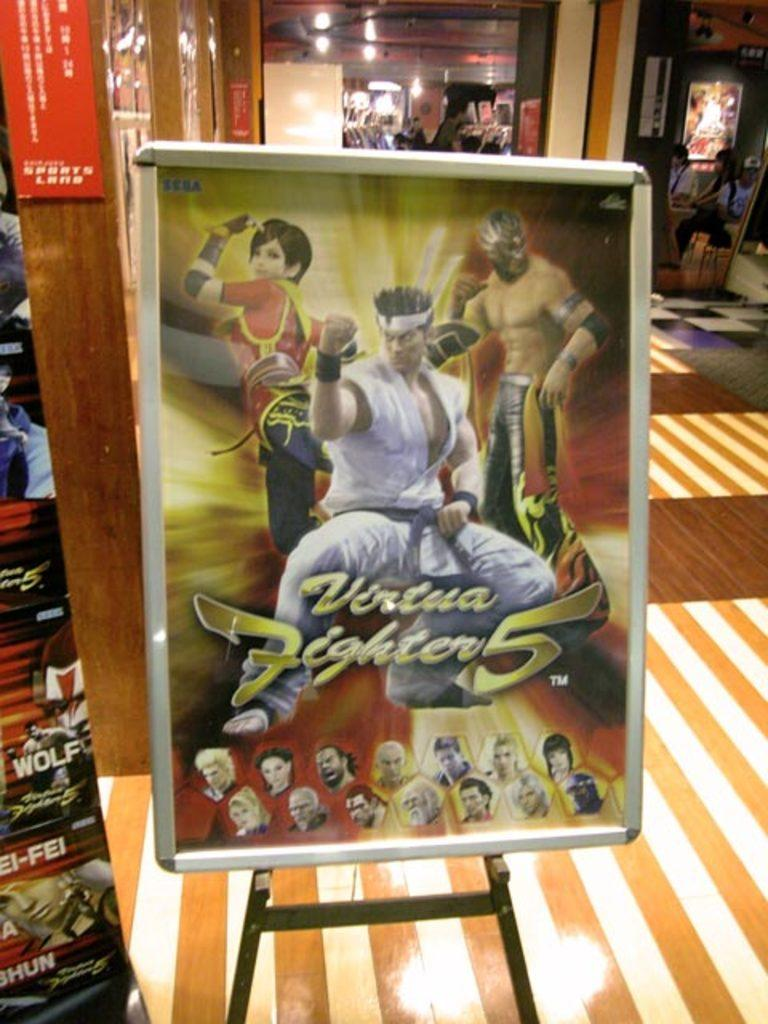<image>
Render a clear and concise summary of the photo. A poster for Virtua Fighter 5 in a room with stripey carpet. 